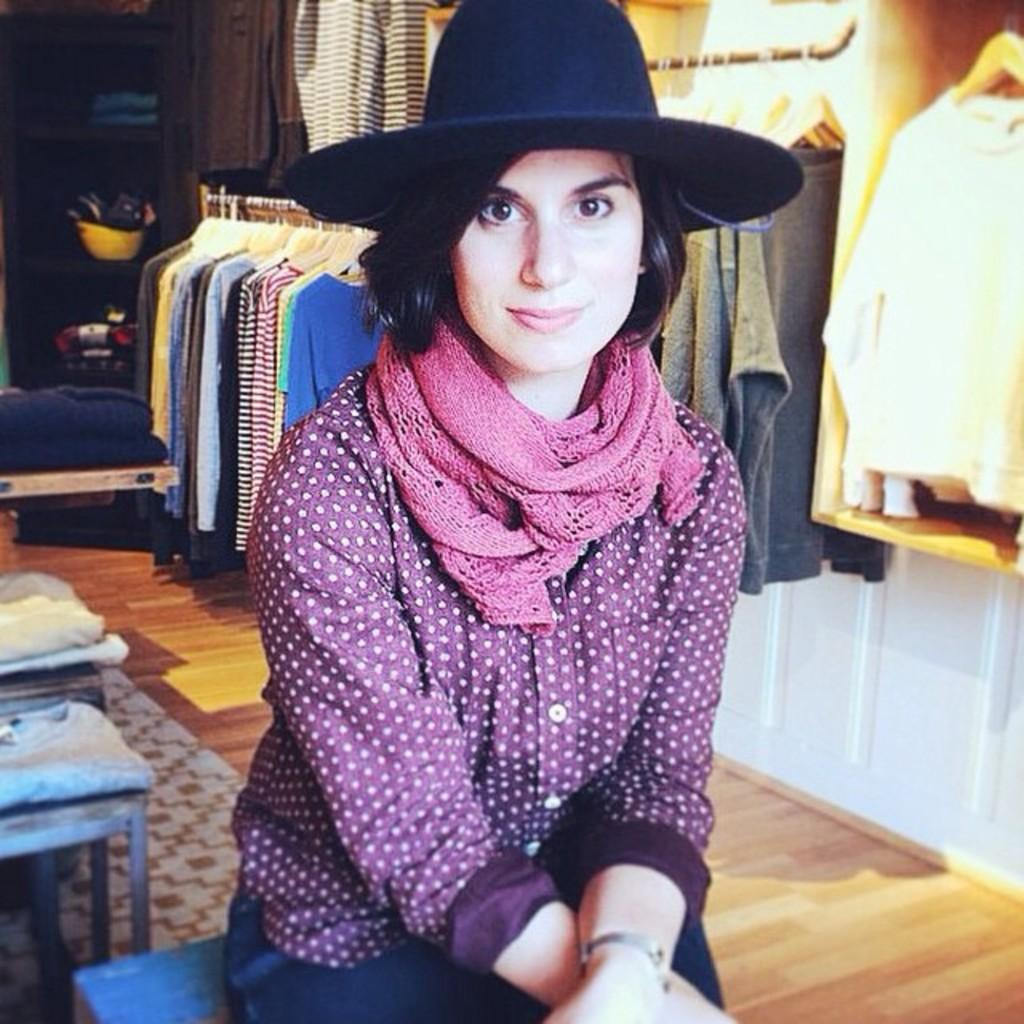What is the person in the image doing? The person is sitting and posing for a picture. Where does the image appear to be taken? The image appears to be taken in a cloth store. What can be seen hanging in the store? Various clothes are hanging in the store. What else is visible in the background of the image? There are other objects visible in the background. What type of songs can be heard playing in the background of the image? There is no indication of any music or songs being played in the image, as it only shows a person posing for a picture in a cloth store. 